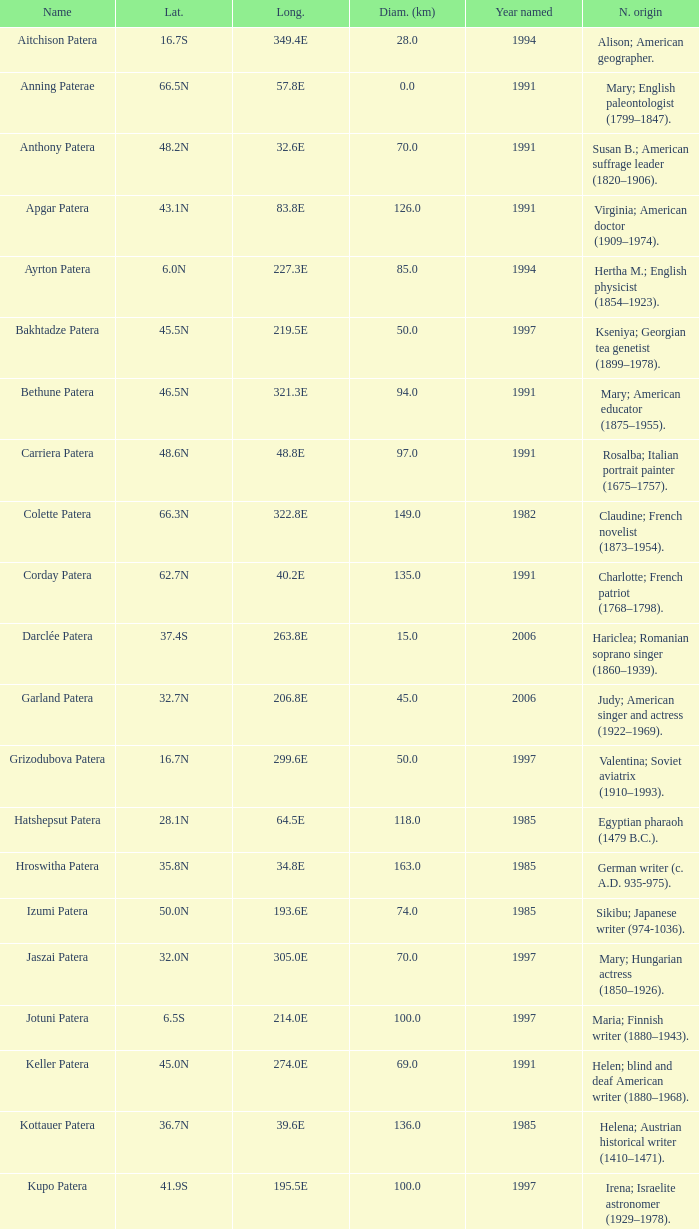What is the diameter in km of the feature named Colette Patera?  149.0. 